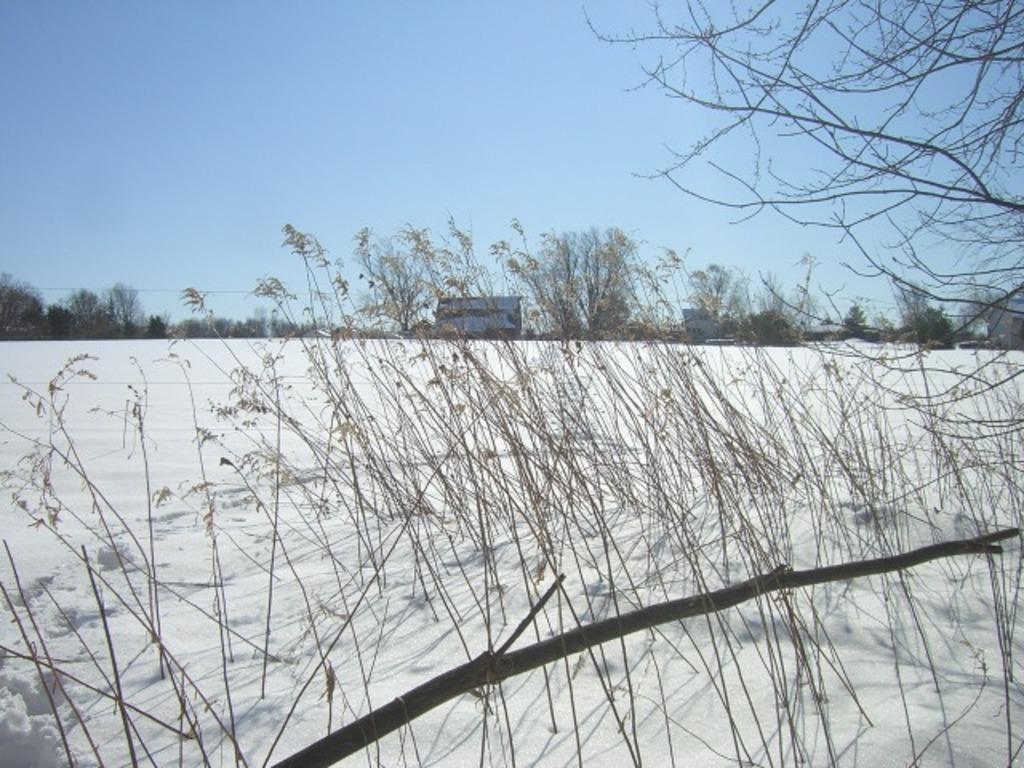Could you give a brief overview of what you see in this image? In the image there are many plants without leaves. And also there are branches without leaves. On the ground there is snow. In the background there are trees. At the top of the image there is a sky. 